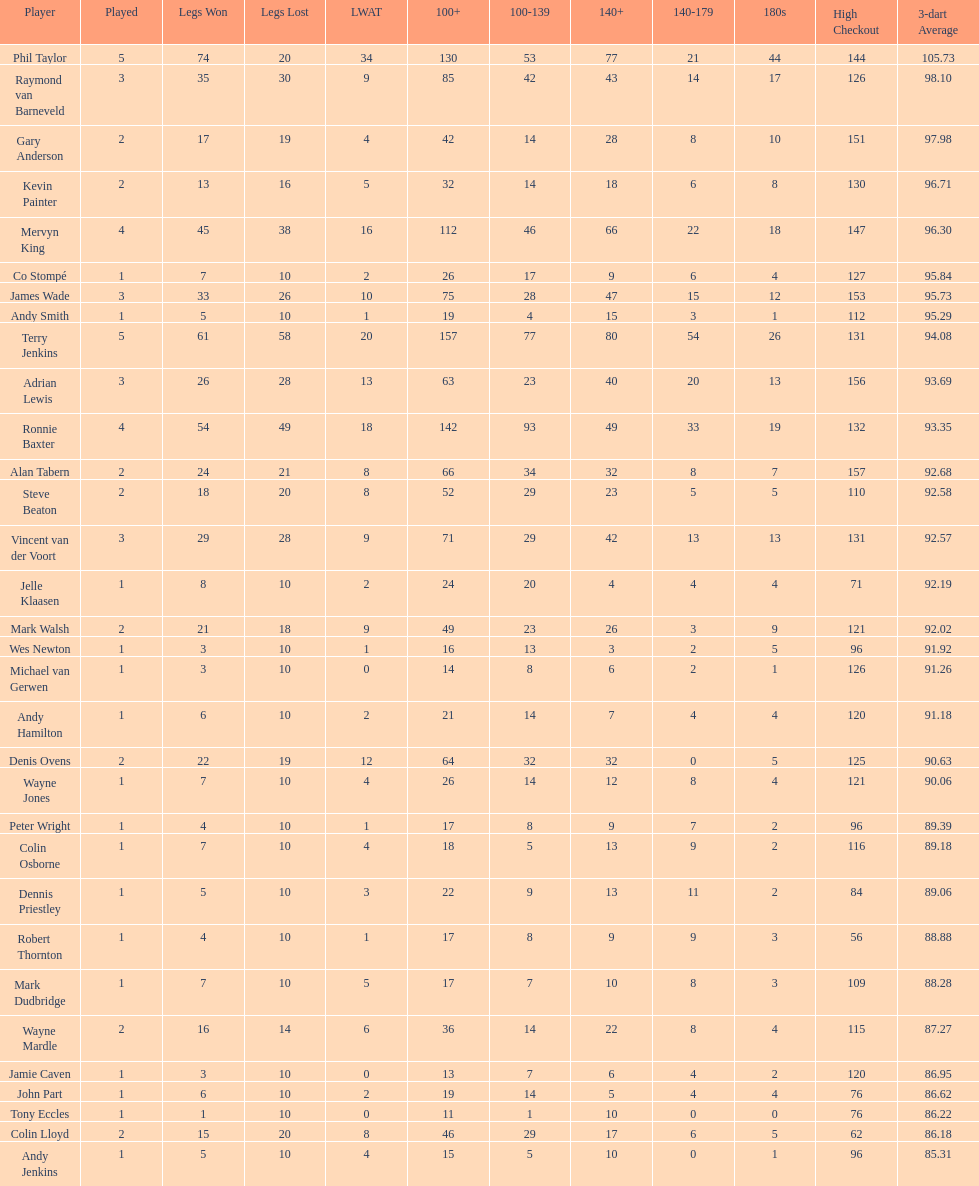How many players have a 3 dart average of more than 97? 3. 